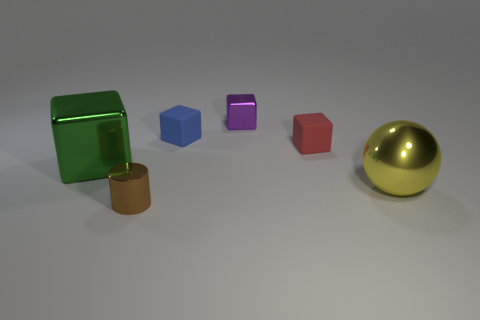Is there a purple metal block left of the large shiny thing that is to the left of the red object?
Provide a succinct answer. No. The other tiny thing that is made of the same material as the brown thing is what color?
Provide a short and direct response. Purple. Is the number of yellow metal balls greater than the number of tiny rubber things?
Your answer should be very brief. No. What number of objects are either tiny matte cubes that are in front of the tiny blue thing or small objects?
Your answer should be very brief. 4. Are there any brown objects of the same size as the green object?
Give a very brief answer. No. Are there fewer matte blocks than big red objects?
Offer a very short reply. No. What number of balls are metallic objects or big shiny objects?
Make the answer very short. 1. How many rubber blocks have the same color as the metallic sphere?
Make the answer very short. 0. What size is the block that is in front of the small blue object and left of the small red rubber block?
Keep it short and to the point. Large. Are there fewer big yellow objects behind the small blue object than small brown shiny cylinders?
Keep it short and to the point. Yes. 